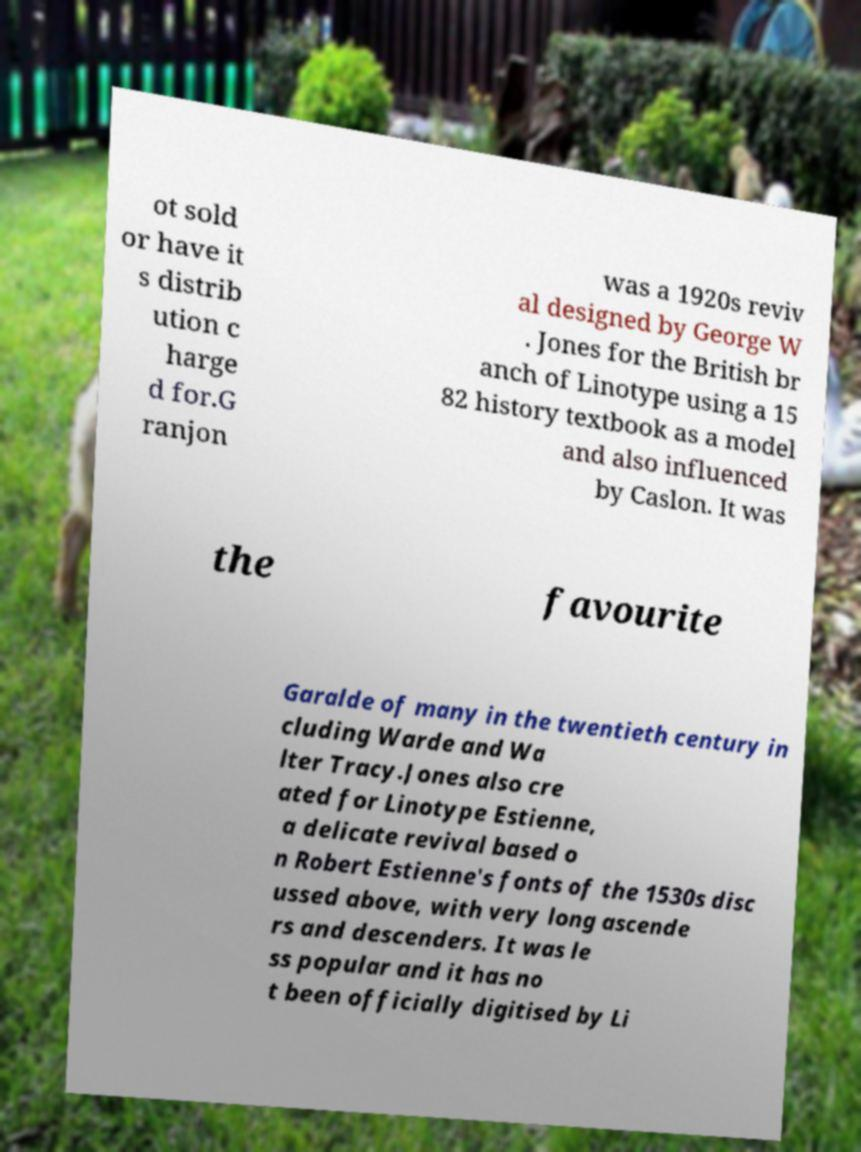For documentation purposes, I need the text within this image transcribed. Could you provide that? ot sold or have it s distrib ution c harge d for.G ranjon was a 1920s reviv al designed by George W . Jones for the British br anch of Linotype using a 15 82 history textbook as a model and also influenced by Caslon. It was the favourite Garalde of many in the twentieth century in cluding Warde and Wa lter Tracy.Jones also cre ated for Linotype Estienne, a delicate revival based o n Robert Estienne's fonts of the 1530s disc ussed above, with very long ascende rs and descenders. It was le ss popular and it has no t been officially digitised by Li 